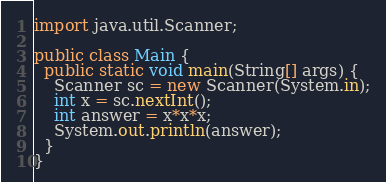<code> <loc_0><loc_0><loc_500><loc_500><_Java_>import java.util.Scanner;

public class Main {
  public static void main(String[] args) {
    Scanner sc = new Scanner(System.in);
    int x = sc.nextInt();
    int answer = x*x*x;
    System.out.println(answer);
  }
}

</code> 